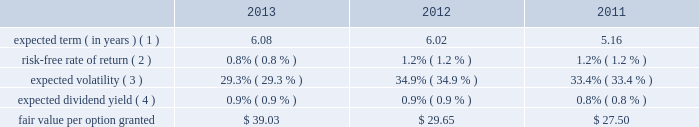Visa inc .
Notes to consolidated financial statements 2014 ( continued ) september 30 , 2013 ( 4 ) participating securities are unvested share-based payment awards that contain non-forfeitable rights to dividends or dividend equivalents , such as the company 2019s restricted stock awards , restricted stock units and earned performance-based shares .
Note 16 2014share-based compensation the company 2019s 2007 equity incentive compensation plan , or the eip , authorizes the compensation committee of the board of directors to grant non-qualified stock options ( 201coptions 201d ) , restricted stock awards ( 201crsas 201d ) , restricted stock units ( 201crsus 201d ) and performance-based shares to its employees and non- employee directors , for up to 59 million shares of class a common stock .
Shares available for award may be either authorized and unissued or previously issued shares subsequently acquired by the company .
The eip will continue to be in effect until all of the common stock available under the eip is delivered and all restrictions on those shares have lapsed , unless the eip is terminated earlier by the company 2019s board of directors .
No awards may be granted under the plan on or after 10 years from its effective date .
Share-based compensation cost is recorded net of estimated forfeitures on a straight-line basis for awards with service conditions only , and on a graded-vesting basis for awards with service , performance and market conditions .
The company 2019s estimated forfeiture rate is based on an evaluation of historical , actual and trended forfeiture data .
For fiscal 2013 , 2012 , and 2011 , the company recorded share-based compensation cost of $ 179 million , $ 147 million and $ 154 million , respectively , in personnel on its consolidated statements of operations .
The amount of capitalized share-based compensation cost was immaterial during fiscal 2013 , 2012 and 2011 .
Options options issued under the eip expire 10 years from the date of grant and vest ratably over three years from the date of grant , subject to earlier vesting in full under certain conditions .
During fiscal 2013 , 2012 and 2011 , the fair value of each stock option was estimated on the date of grant using a black-scholes option pricing model with the following weighted-average assumptions: .
( 1 ) based on a set of peer companies that management believes is generally comparable to visa .
( 2 ) based upon the zero coupon u.s .
Treasury bond rate over the expected term of the awards .
( 3 ) based on the average of the company 2019s implied and historical volatility .
As the company 2019s publicly-traded stock history is relatively short , historical volatility relies in part on the historical volatility of a group of peer companies that management believes is generally comparable to visa .
The relative weighting between visa historical volatility and the historical volatility of the peer companies is based on the percentage of years visa stock price information has been available since its initial public offering compared to the expected term .
The expected volatilities ranged from 27% ( 27 % ) to 29% ( 29 % ) in fiscal 2013 .
( 4 ) based on the company 2019s annual dividend rate on the date of grant. .
What is the percentage change in fair value of option from 2012 to 2013? 
Computations: (39.03 - 29.65)
Answer: 9.38. 